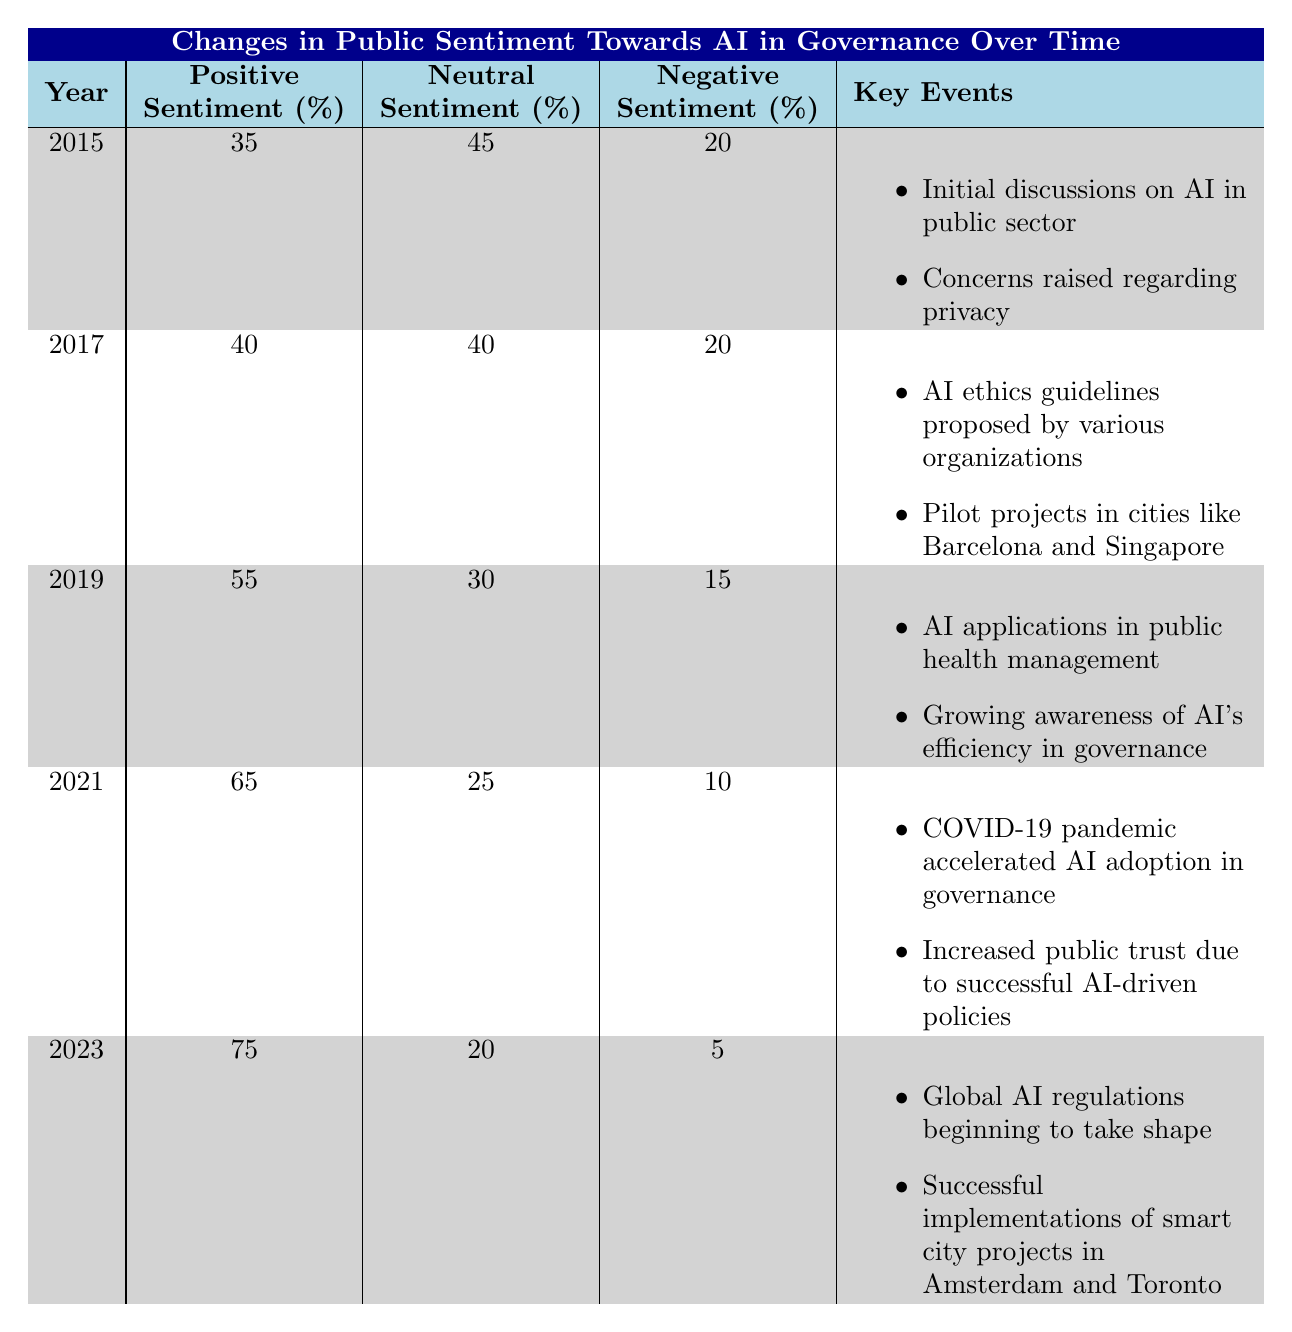What was the percentage of positive sentiment towards AI governance in 2015? In the table, under the year 2015, the Positive Sentiment Percentage is listed as 35%.
Answer: 35% What was the trend in negative sentiment from 2015 to 2023? In 2015, the Negative Sentiment Percentage was 20%. By 2023, it decreased to 5%. This indicates a decreasing trend in negative sentiment over the years.
Answer: Decreasing What was the average positive sentiment percentage from 2015 to 2023? To find the average, sum the positive sentiment percentages from each year: (35 + 40 + 55 + 65 + 75) = 270. There are 5 data points, so the average is 270/5 = 54.
Answer: 54 In which year did positive sentiment first exceed 50%? Reviewing the table, positive sentiment exceeded 50% for the first time in 2019, where it reached 55%.
Answer: 2019 Were there more neutral or negative sentiments in 2021? In 2021, the Neutral Sentiment Percentage was 25%, while the Negative Sentiment Percentage was 10%. Since 25% is greater than 10%, there were more neutral sentiments in that year.
Answer: Yes What events contributed to the increase in positive sentiment between 2019 and 2021? In 2019, key events included AI applications in public health management and growing awareness of AI's efficiency. In 2021, significant events were the acceleration of AI adoption due to COVID-19 and increased public trust from successful AI-driven policies. These factors contributed to the rise in positive sentiment from 55% in 2019 to 65% in 2021.
Answer: COVID-19 and successful policies Was there ever a year when the negative sentiment percentage was above 15%? The Negative Sentiment Percentages were 20% in 2015, 20% in 2017, and 15% in 2019. Since 20% is greater than 15%, the answer is yes, there were years when negative sentiment was above 15%.
Answer: Yes What shift can we observe in public sentiment between 2019 and 2023, particularly in positive sentiment? The Positive Sentiment Percentage increased from 55% in 2019 to 75% in 2023. This represents a significant shift of 20 percentage points, indicating an improvement in public sentiment towards AI governance over this period.
Answer: Increased by 20 percentage points In what year was the neutral sentiment the highest, and what was its percentage? The Neutral Sentiment Percentage was highest in 2015 at 45%.
Answer: 2015, 45% 